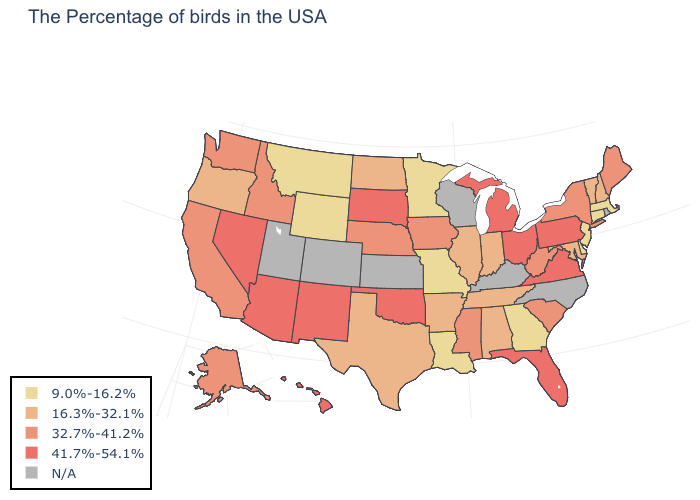What is the highest value in states that border Washington?
Answer briefly. 32.7%-41.2%. Among the states that border Wisconsin , does Michigan have the highest value?
Write a very short answer. Yes. Does the first symbol in the legend represent the smallest category?
Be succinct. Yes. What is the value of Wyoming?
Concise answer only. 9.0%-16.2%. What is the value of Alabama?
Give a very brief answer. 16.3%-32.1%. Which states have the lowest value in the USA?
Give a very brief answer. Massachusetts, Connecticut, New Jersey, Delaware, Georgia, Louisiana, Missouri, Minnesota, Wyoming, Montana. Name the states that have a value in the range N/A?
Give a very brief answer. Rhode Island, North Carolina, Kentucky, Wisconsin, Kansas, Colorado, Utah. Name the states that have a value in the range 41.7%-54.1%?
Give a very brief answer. Pennsylvania, Virginia, Ohio, Florida, Michigan, Oklahoma, South Dakota, New Mexico, Arizona, Nevada, Hawaii. Name the states that have a value in the range 41.7%-54.1%?
Keep it brief. Pennsylvania, Virginia, Ohio, Florida, Michigan, Oklahoma, South Dakota, New Mexico, Arizona, Nevada, Hawaii. Does Nebraska have the highest value in the MidWest?
Short answer required. No. Does Connecticut have the lowest value in the Northeast?
Concise answer only. Yes. What is the lowest value in the MidWest?
Concise answer only. 9.0%-16.2%. What is the lowest value in the USA?
Be succinct. 9.0%-16.2%. Among the states that border Michigan , does Ohio have the lowest value?
Quick response, please. No. Does New Jersey have the lowest value in the Northeast?
Write a very short answer. Yes. 